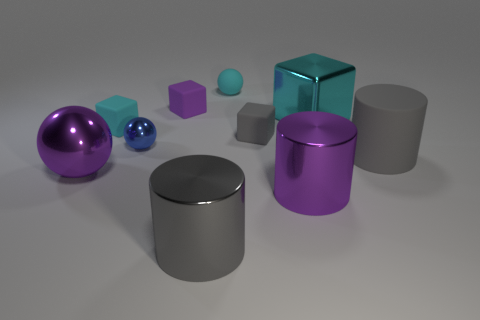The gray shiny cylinder has what size?
Offer a very short reply. Large. Does the metallic cube have the same size as the sphere behind the small blue thing?
Keep it short and to the point. No. What color is the metallic ball that is behind the purple object that is left of the tiny blue metal thing?
Offer a terse response. Blue. Are there an equal number of big metallic blocks behind the tiny purple thing and tiny cubes that are behind the tiny cyan cube?
Offer a very short reply. No. Is the purple object behind the big block made of the same material as the purple cylinder?
Your response must be concise. No. What color is the sphere that is both behind the large rubber cylinder and left of the purple cube?
Your answer should be very brief. Blue. There is a matte object on the right side of the cyan metallic object; how many tiny rubber balls are in front of it?
Give a very brief answer. 0. There is a large purple object that is the same shape as the tiny metallic thing; what is it made of?
Provide a short and direct response. Metal. The big matte cylinder is what color?
Provide a short and direct response. Gray. How many things are either large cyan blocks or gray shiny objects?
Give a very brief answer. 2. 